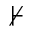<formula> <loc_0><loc_0><loc_500><loc_500>\nvdash</formula> 